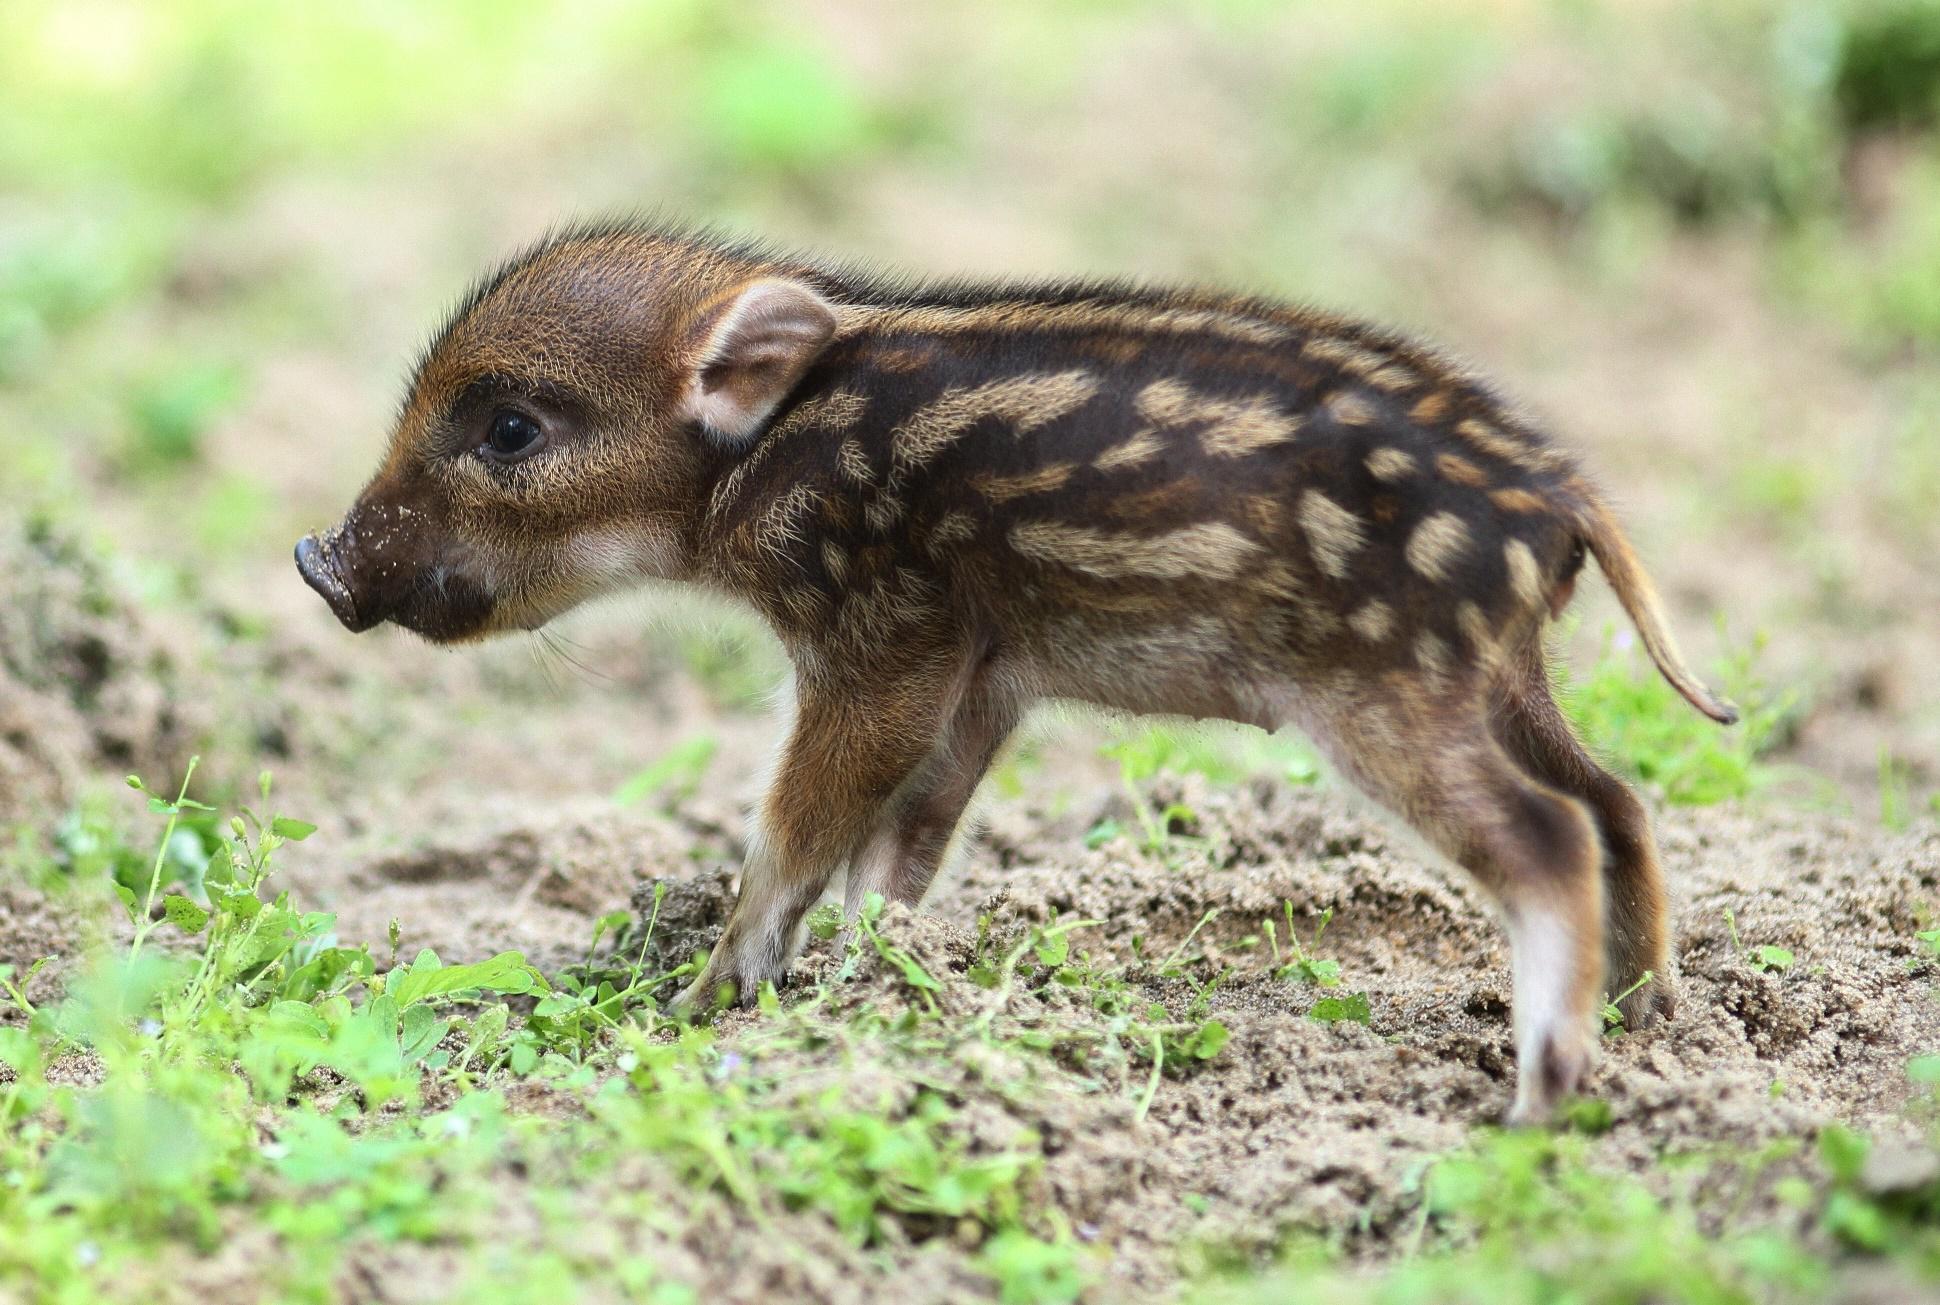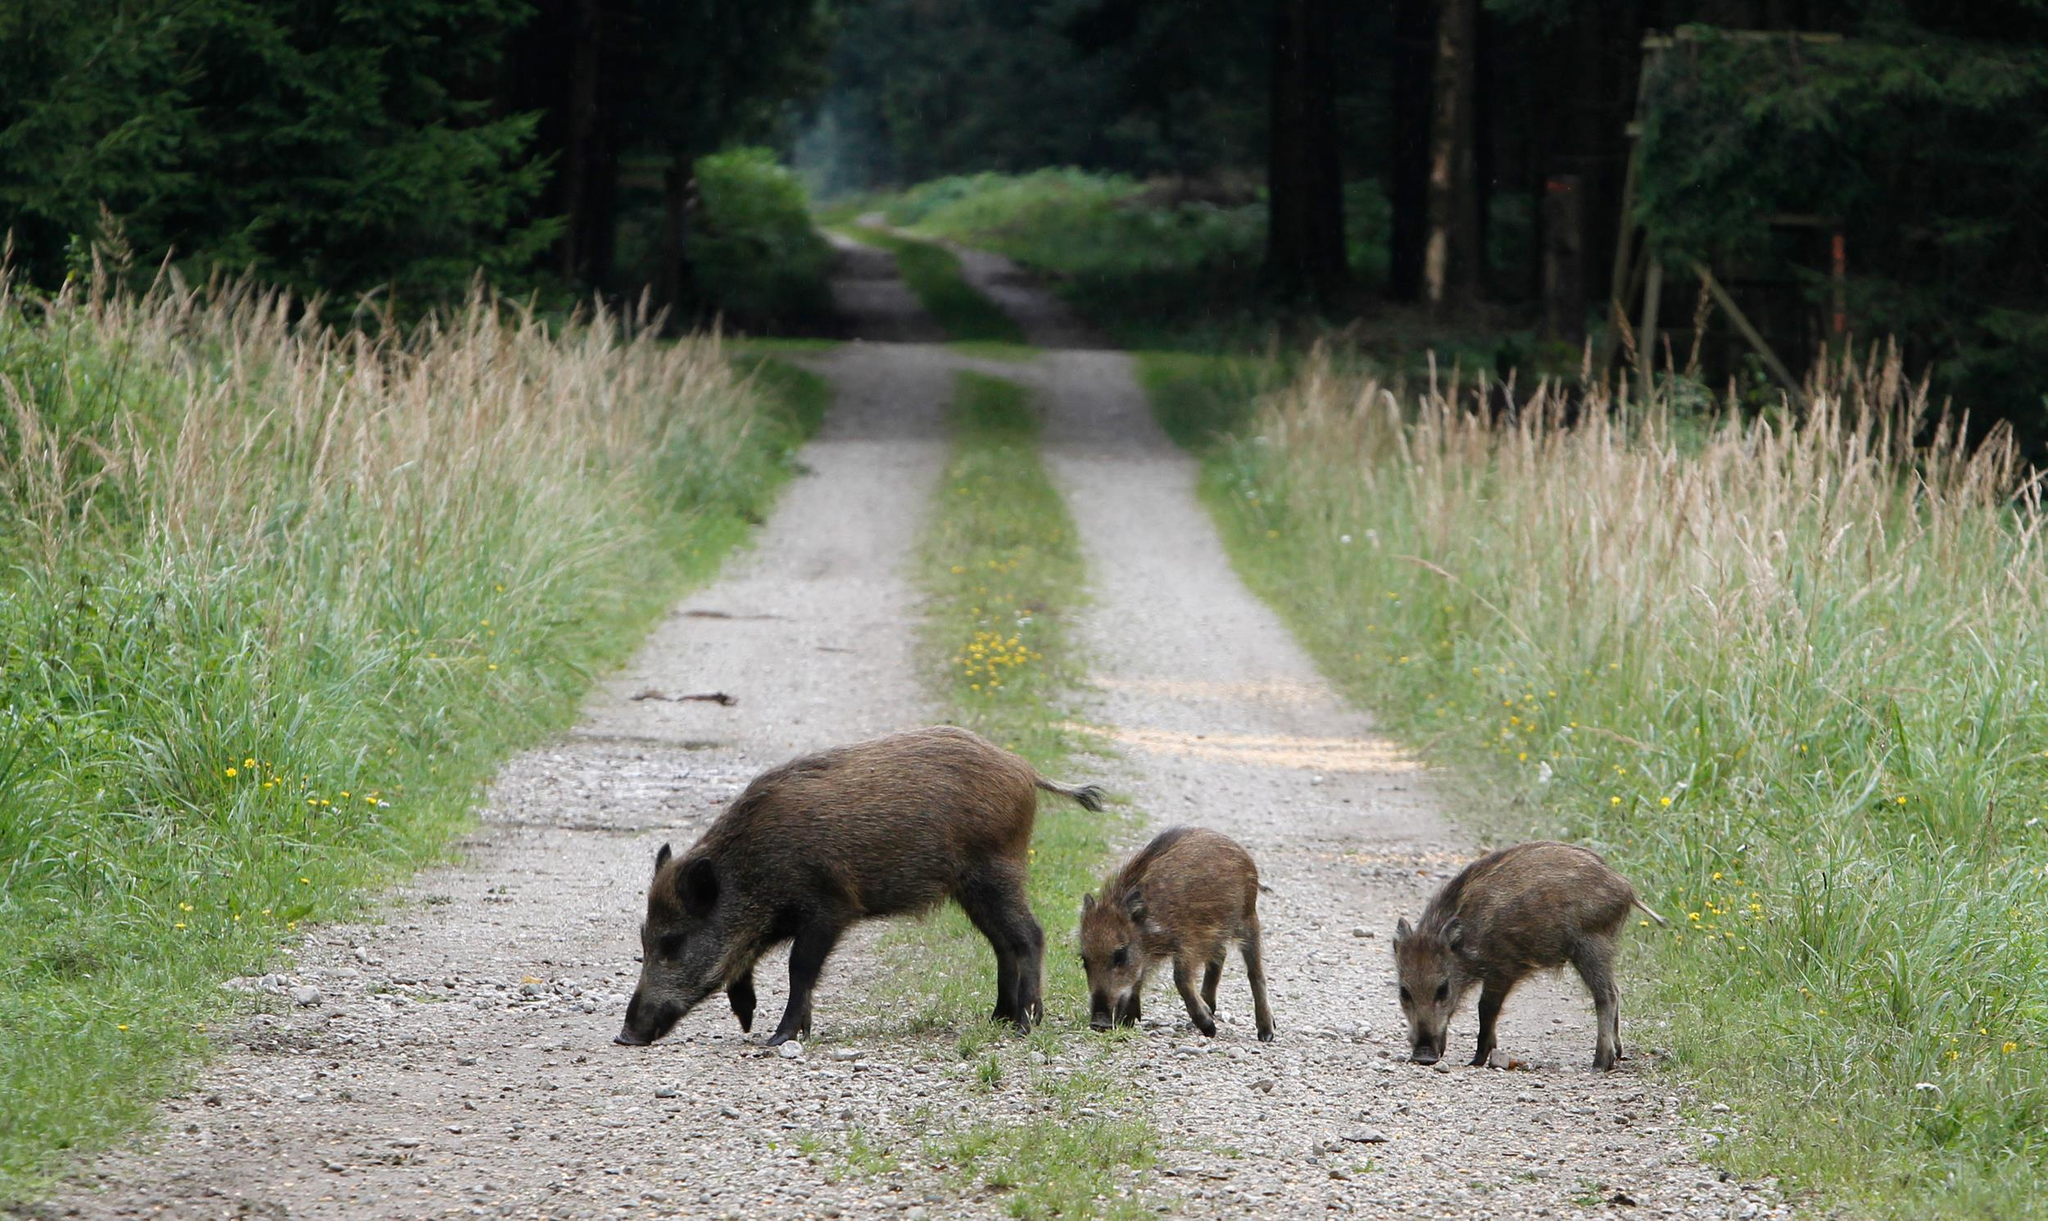The first image is the image on the left, the second image is the image on the right. For the images shown, is this caption "There is a human feeding one of the pigs." true? Answer yes or no. No. The first image is the image on the left, the second image is the image on the right. For the images displayed, is the sentence "There is at least one image in which there is a person near the boar." factually correct? Answer yes or no. No. 